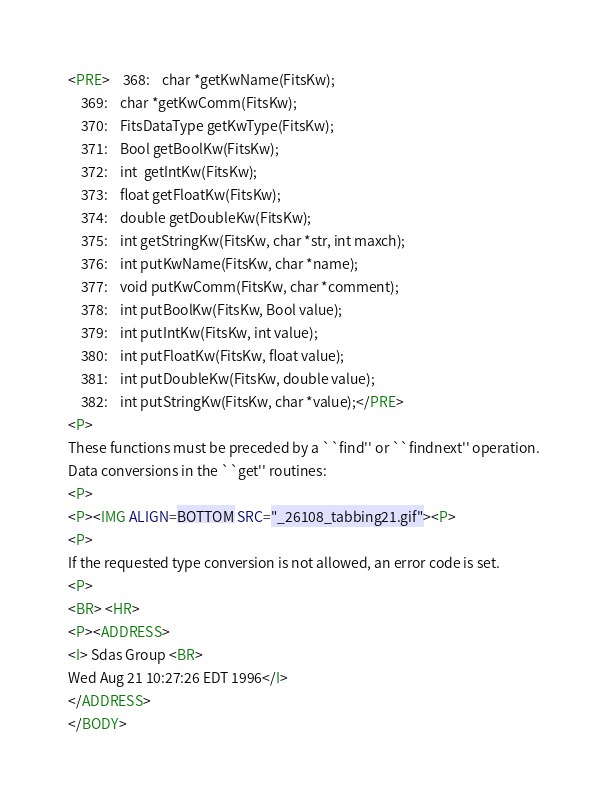Convert code to text. <code><loc_0><loc_0><loc_500><loc_500><_HTML_><PRE>    368:    char *getKwName(FitsKw);
    369:    char *getKwComm(FitsKw);
    370:    FitsDataType getKwType(FitsKw);
    371:    Bool getBoolKw(FitsKw);
    372:    int  getIntKw(FitsKw);
    373:    float getFloatKw(FitsKw);
    374:    double getDoubleKw(FitsKw);
    375:    int getStringKw(FitsKw, char *str, int maxch);
    376:    int putKwName(FitsKw, char *name);
    377:    void putKwComm(FitsKw, char *comment);
    378:    int putBoolKw(FitsKw, Bool value);
    379:    int putIntKw(FitsKw, int value);
    380:    int putFloatKw(FitsKw, float value);
    381:    int putDoubleKw(FitsKw, double value);
    382:    int putStringKw(FitsKw, char *value);</PRE>
<P>
These functions must be preceded by a ``find'' or ``findnext'' operation.
Data conversions in the ``get'' routines:
<P>
<P><IMG ALIGN=BOTTOM SRC="_26108_tabbing21.gif"><P>
<P>
If the requested type conversion is not allowed, an error code is set.
<P>
<BR> <HR>
<P><ADDRESS>
<I> Sdas Group <BR>
Wed Aug 21 10:27:26 EDT 1996</I>
</ADDRESS>
</BODY>
</code> 